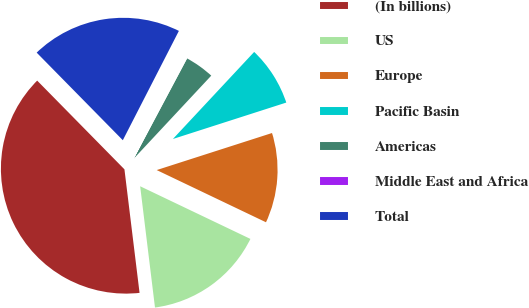Convert chart. <chart><loc_0><loc_0><loc_500><loc_500><pie_chart><fcel>(In billions)<fcel>US<fcel>Europe<fcel>Pacific Basin<fcel>Americas<fcel>Middle East and Africa<fcel>Total<nl><fcel>39.57%<fcel>15.97%<fcel>12.04%<fcel>8.1%<fcel>4.17%<fcel>0.24%<fcel>19.91%<nl></chart> 